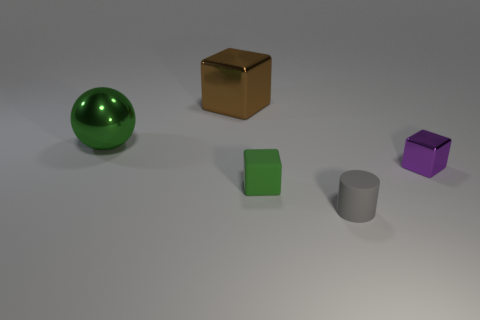Subtract all small cubes. How many cubes are left? 1 Subtract all green cubes. How many cubes are left? 2 Subtract 2 cubes. How many cubes are left? 1 Add 2 large spheres. How many large spheres are left? 3 Add 5 large gray matte objects. How many large gray matte objects exist? 5 Add 2 tiny yellow metal things. How many objects exist? 7 Subtract 0 yellow blocks. How many objects are left? 5 Subtract all balls. How many objects are left? 4 Subtract all yellow blocks. Subtract all brown cylinders. How many blocks are left? 3 Subtract all cyan balls. How many green cubes are left? 1 